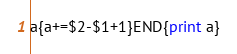<code> <loc_0><loc_0><loc_500><loc_500><_Awk_>a{a+=$2-$1+1}END{print a}</code> 